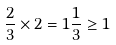Convert formula to latex. <formula><loc_0><loc_0><loc_500><loc_500>\frac { 2 } { 3 } \times 2 = 1 \frac { 1 } { 3 } \geq 1</formula> 